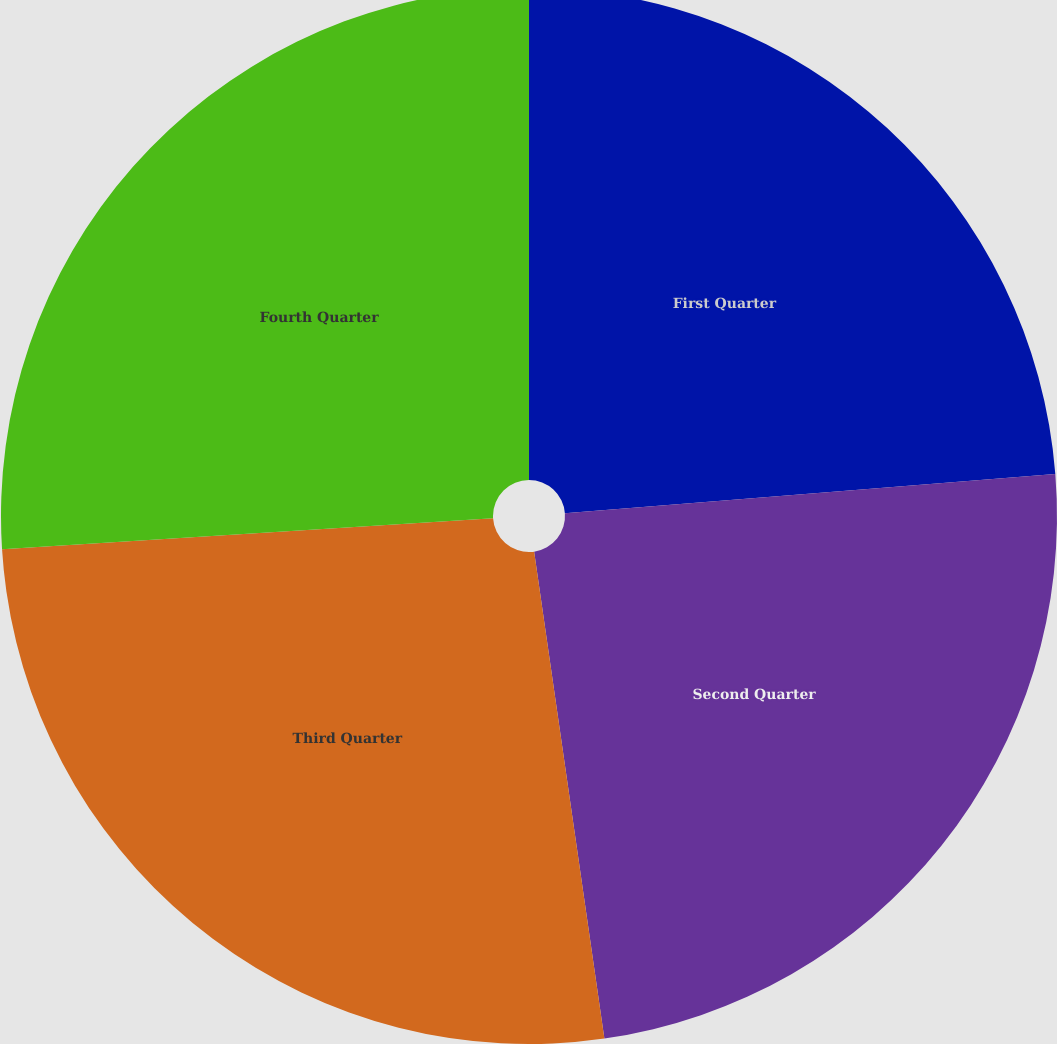Convert chart to OTSL. <chart><loc_0><loc_0><loc_500><loc_500><pie_chart><fcel>First Quarter<fcel>Second Quarter<fcel>Third Quarter<fcel>Fourth Quarter<nl><fcel>23.73%<fcel>23.99%<fcel>26.28%<fcel>26.0%<nl></chart> 